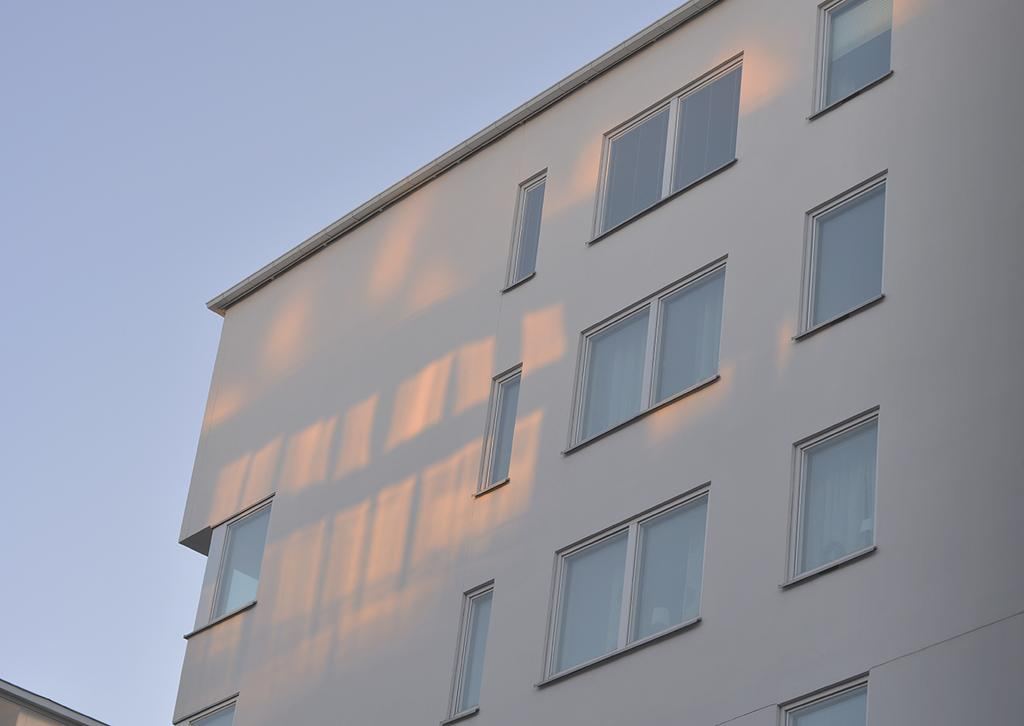What type of building is visible in the image? There is a building with glass windows in the image. What can be seen in the background of the image? The sky is visible in the background of the image. Where is the wall located in the image? The wall is on the left side bottom of the image. How many fish are swimming in the wall in the image? There are no fish present in the image, and the wall does not contain any water for fish to swim in. 